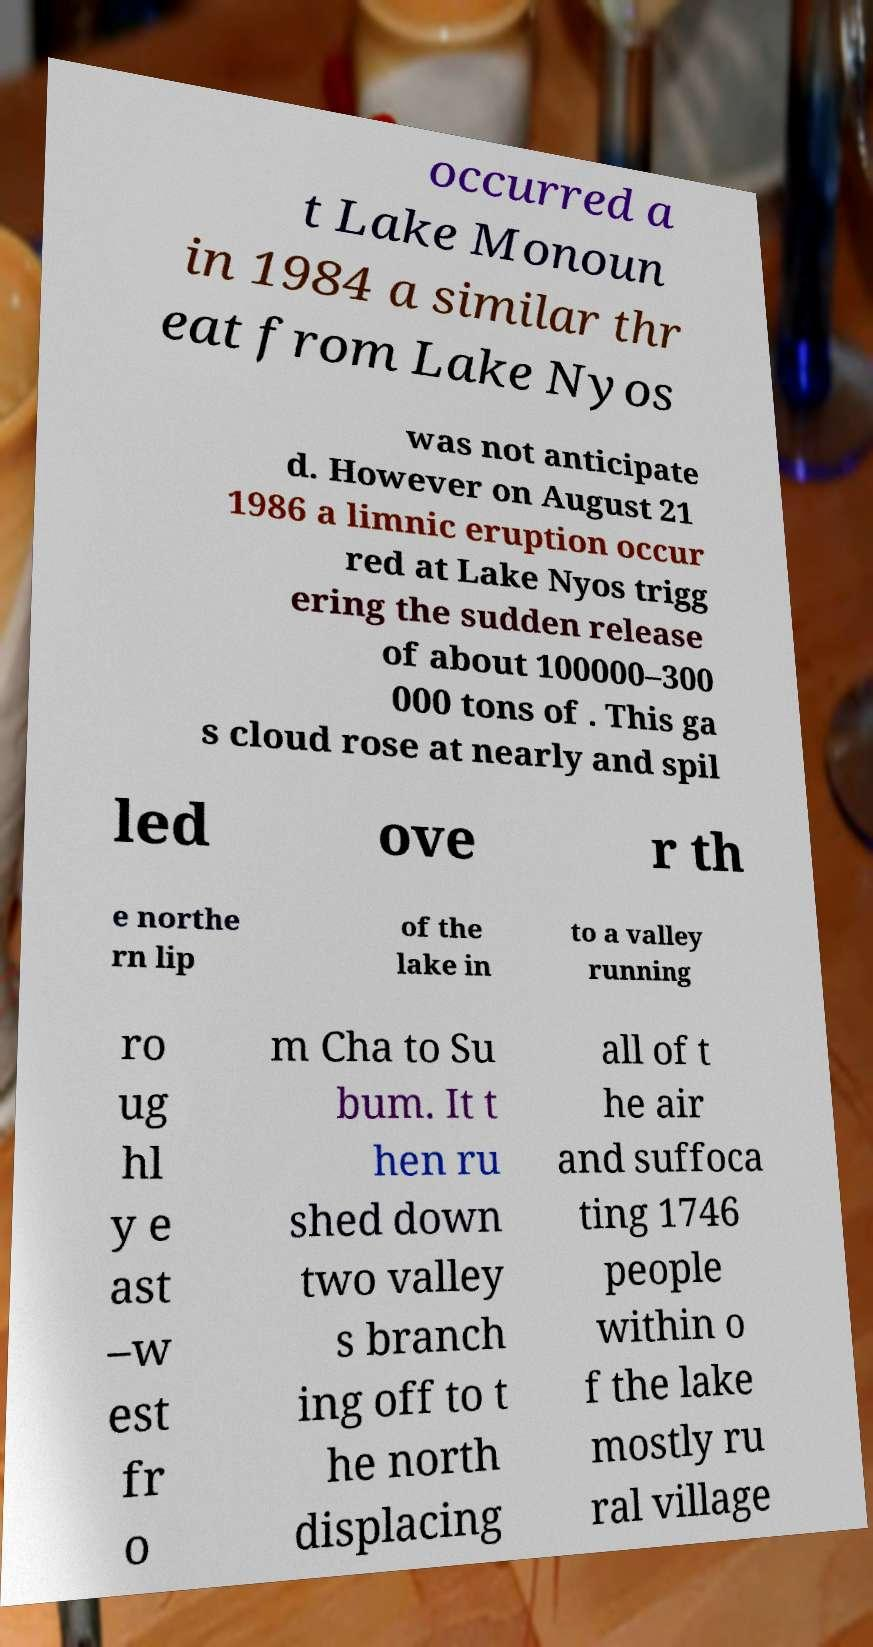Please identify and transcribe the text found in this image. occurred a t Lake Monoun in 1984 a similar thr eat from Lake Nyos was not anticipate d. However on August 21 1986 a limnic eruption occur red at Lake Nyos trigg ering the sudden release of about 100000–300 000 tons of . This ga s cloud rose at nearly and spil led ove r th e northe rn lip of the lake in to a valley running ro ug hl y e ast –w est fr o m Cha to Su bum. It t hen ru shed down two valley s branch ing off to t he north displacing all of t he air and suffoca ting 1746 people within o f the lake mostly ru ral village 